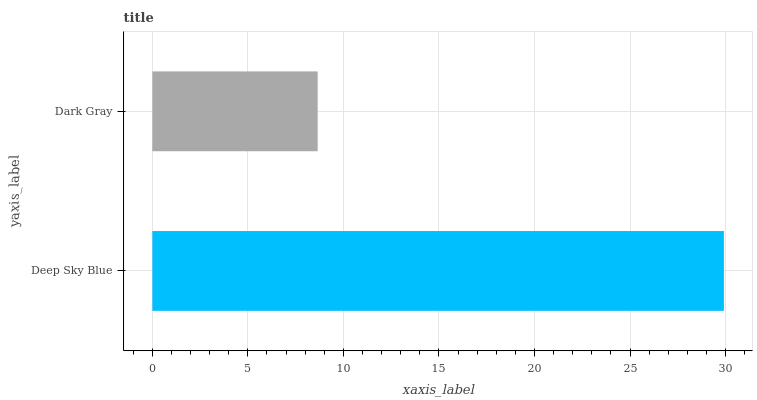Is Dark Gray the minimum?
Answer yes or no. Yes. Is Deep Sky Blue the maximum?
Answer yes or no. Yes. Is Dark Gray the maximum?
Answer yes or no. No. Is Deep Sky Blue greater than Dark Gray?
Answer yes or no. Yes. Is Dark Gray less than Deep Sky Blue?
Answer yes or no. Yes. Is Dark Gray greater than Deep Sky Blue?
Answer yes or no. No. Is Deep Sky Blue less than Dark Gray?
Answer yes or no. No. Is Deep Sky Blue the high median?
Answer yes or no. Yes. Is Dark Gray the low median?
Answer yes or no. Yes. Is Dark Gray the high median?
Answer yes or no. No. Is Deep Sky Blue the low median?
Answer yes or no. No. 